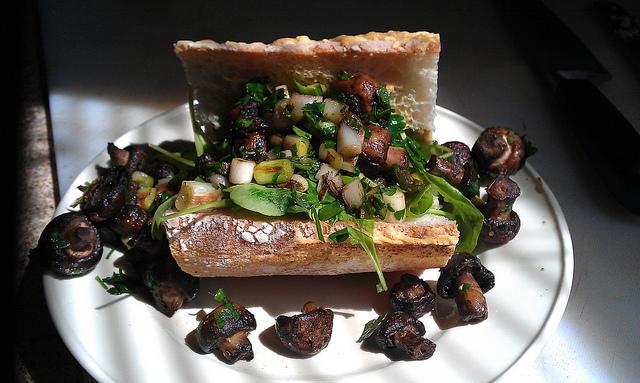What colors are the food?
Give a very brief answer. Brown. What is on the plate?
Answer briefly. Sandwich. Is this a vegan dish?
Quick response, please. Yes. 